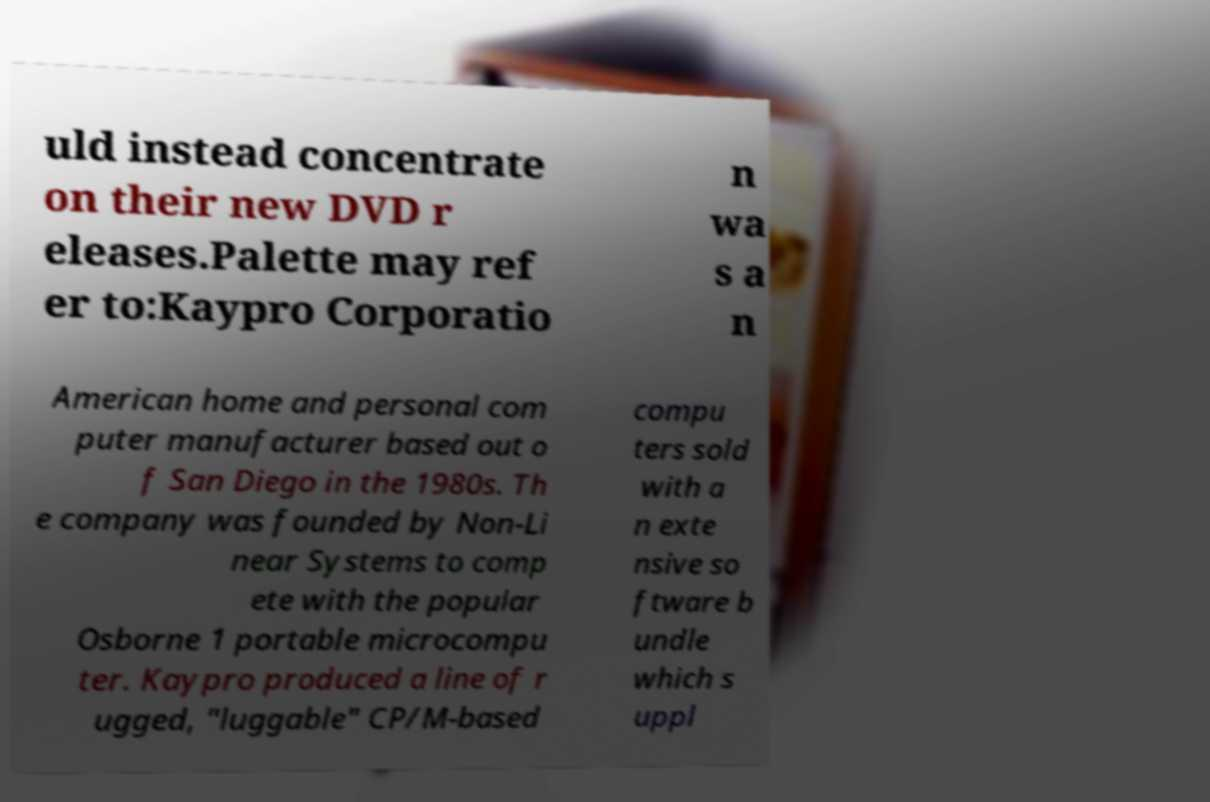Please identify and transcribe the text found in this image. uld instead concentrate on their new DVD r eleases.Palette may ref er to:Kaypro Corporatio n wa s a n American home and personal com puter manufacturer based out o f San Diego in the 1980s. Th e company was founded by Non-Li near Systems to comp ete with the popular Osborne 1 portable microcompu ter. Kaypro produced a line of r ugged, "luggable" CP/M-based compu ters sold with a n exte nsive so ftware b undle which s uppl 